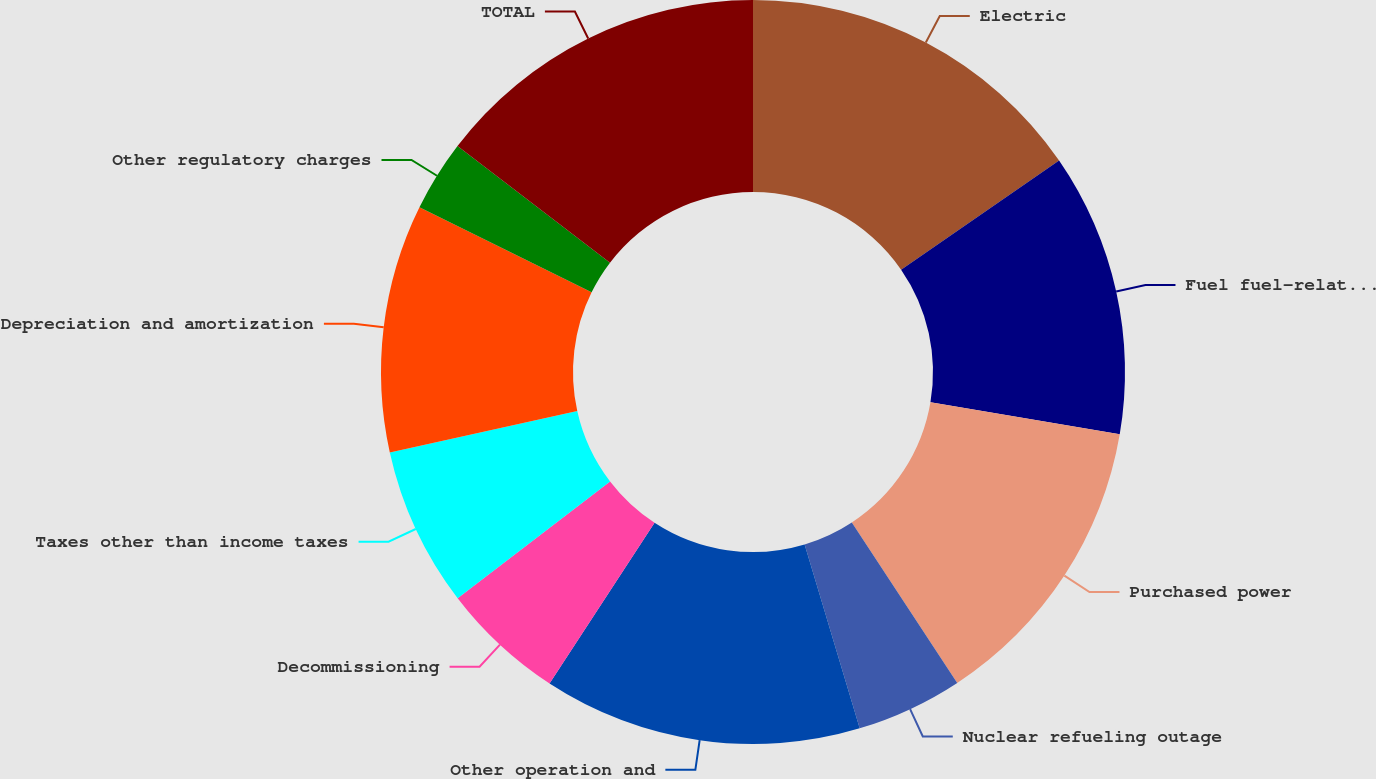<chart> <loc_0><loc_0><loc_500><loc_500><pie_chart><fcel>Electric<fcel>Fuel fuel-related expenses and<fcel>Purchased power<fcel>Nuclear refueling outage<fcel>Other operation and<fcel>Decommissioning<fcel>Taxes other than income taxes<fcel>Depreciation and amortization<fcel>Other regulatory charges<fcel>TOTAL<nl><fcel>15.38%<fcel>12.3%<fcel>13.07%<fcel>4.62%<fcel>13.84%<fcel>5.39%<fcel>6.93%<fcel>10.77%<fcel>3.09%<fcel>14.61%<nl></chart> 